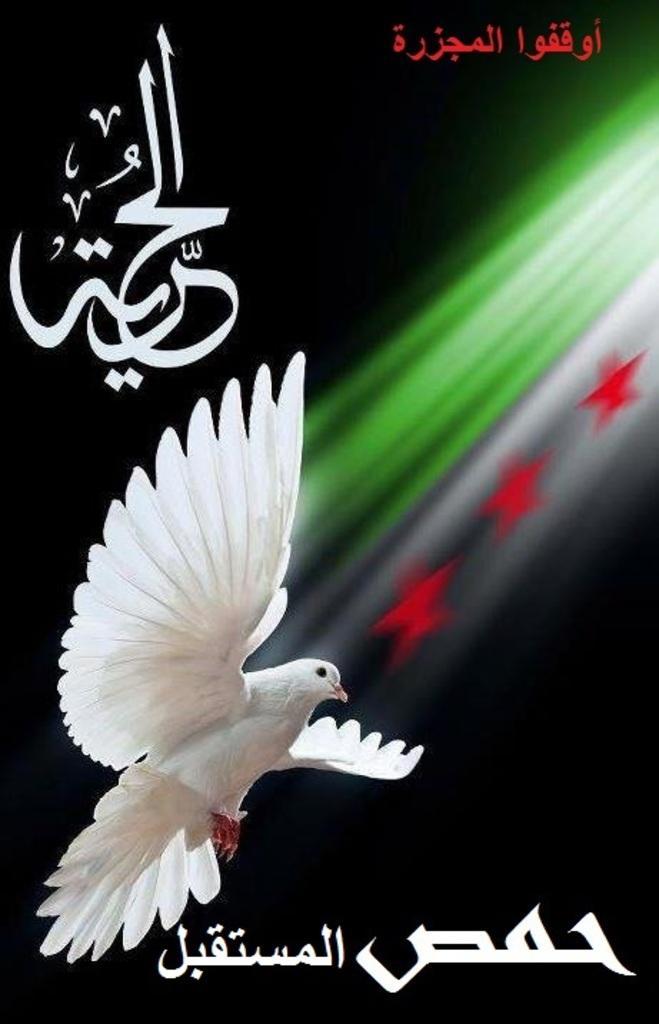Can you describe this image briefly? In the image we can see there is a poster on which matter is written in arabic language and there is a dove bird flying. There are three red colour stars. 